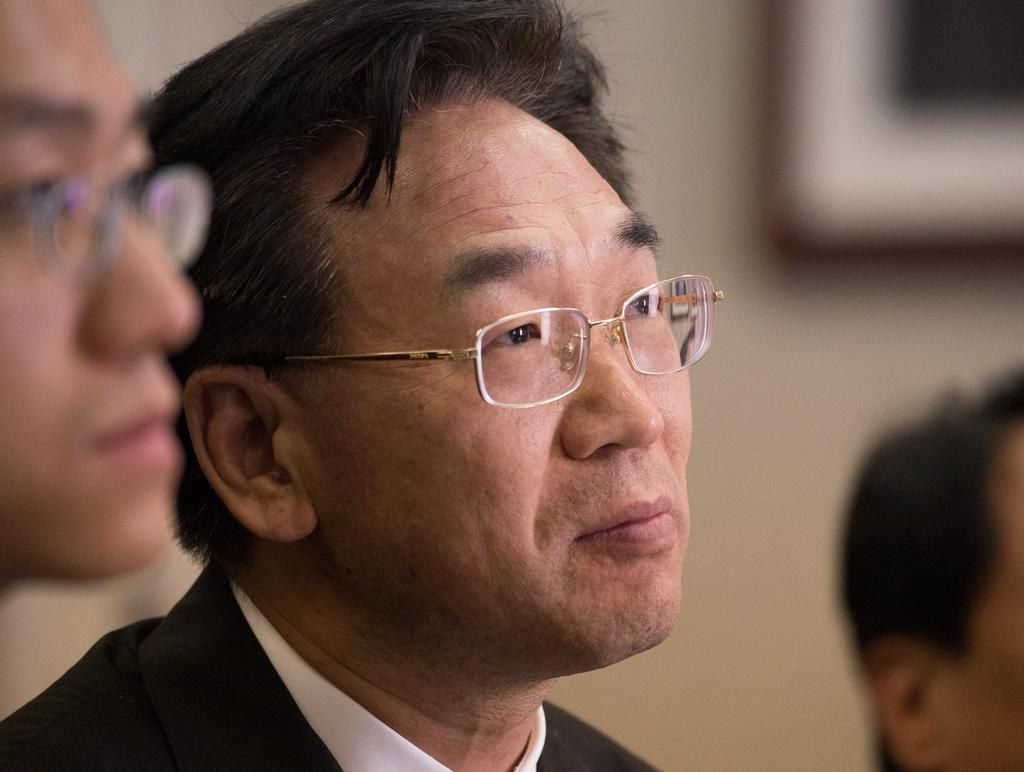What is the main subject of the image? There is a man in the middle of the image. Can you describe the man's appearance? The man is wearing clothes and spectacles. Are there any other people in the image? Yes, there are other people sitting beside the man. How would you describe the background of the image? The background of the image is blurred. What type of tail can be seen on the man in the image? There is no tail visible on the man in the image. How does the man perform the trick in the image? There is no trick being performed by the man in the image. 